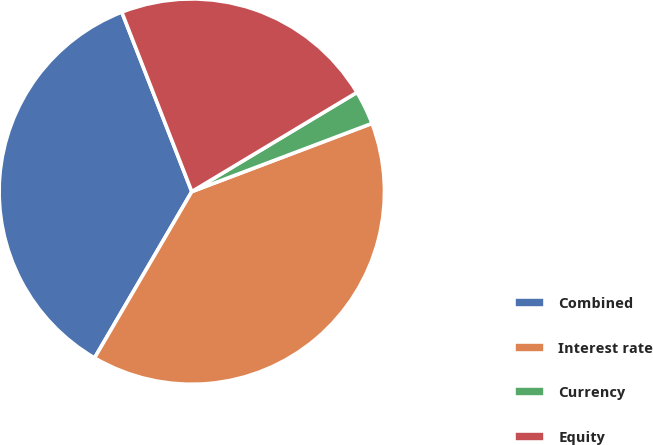<chart> <loc_0><loc_0><loc_500><loc_500><pie_chart><fcel>Combined<fcel>Interest rate<fcel>Currency<fcel>Equity<nl><fcel>35.66%<fcel>39.18%<fcel>2.85%<fcel>22.31%<nl></chart> 